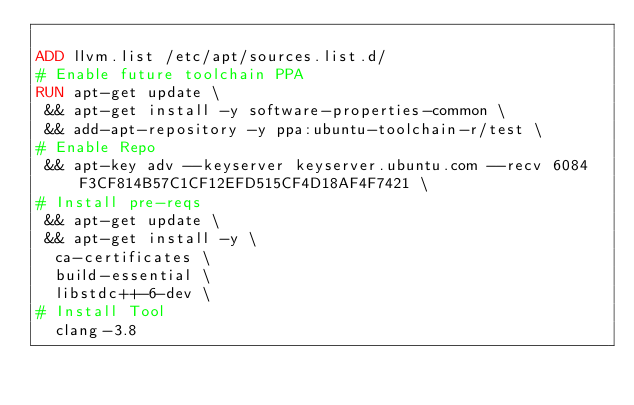<code> <loc_0><loc_0><loc_500><loc_500><_Dockerfile_>
ADD llvm.list /etc/apt/sources.list.d/
# Enable future toolchain PPA
RUN apt-get update \
 && apt-get install -y software-properties-common \
 && add-apt-repository -y ppa:ubuntu-toolchain-r/test \
# Enable Repo
 && apt-key adv --keyserver keyserver.ubuntu.com --recv 6084F3CF814B57C1CF12EFD515CF4D18AF4F7421 \
# Install pre-reqs
 && apt-get update \
 && apt-get install -y \
  ca-certificates \
  build-essential \
  libstdc++-6-dev \
# Install Tool
  clang-3.8
</code> 